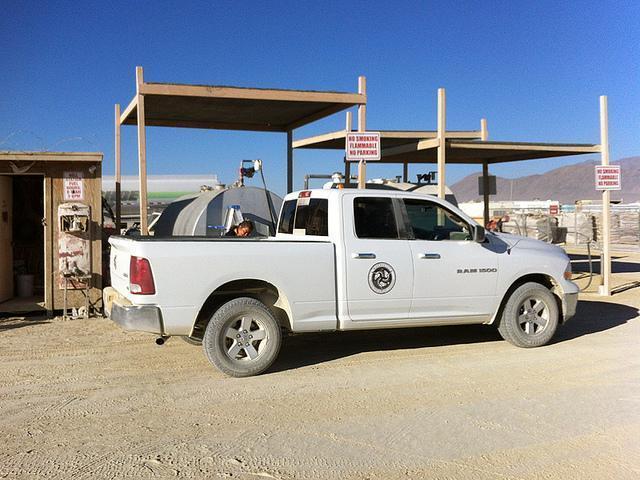How many double cab trucks can be seen?
Give a very brief answer. 1. How many cars in this picture?
Give a very brief answer. 1. How many rolls of white toilet paper are in the bathroom?
Give a very brief answer. 0. 